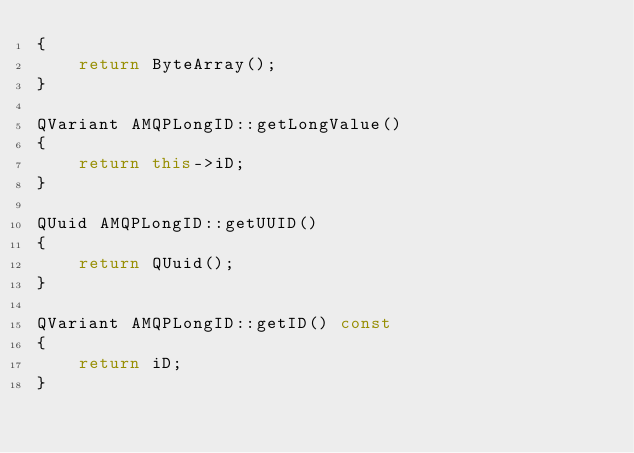Convert code to text. <code><loc_0><loc_0><loc_500><loc_500><_C++_>{
    return ByteArray();
}

QVariant AMQPLongID::getLongValue()
{
    return this->iD;
}

QUuid AMQPLongID::getUUID()
{
    return QUuid();
}

QVariant AMQPLongID::getID() const
{
    return iD;
}
</code> 